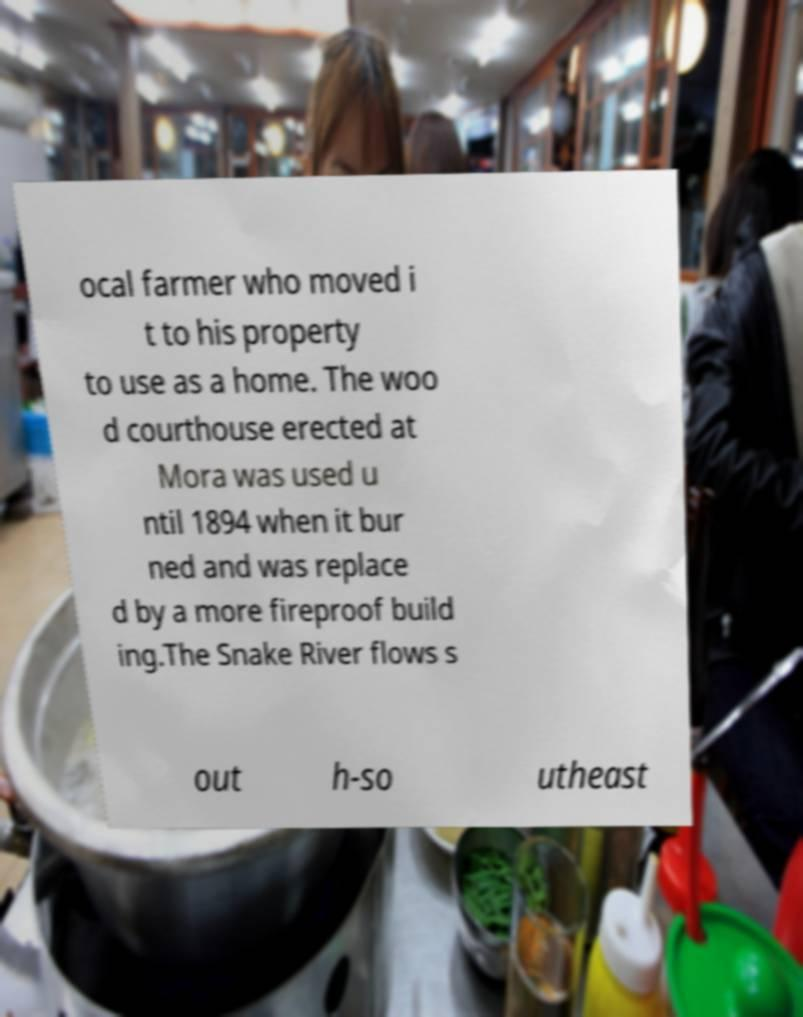Please read and relay the text visible in this image. What does it say? ocal farmer who moved i t to his property to use as a home. The woo d courthouse erected at Mora was used u ntil 1894 when it bur ned and was replace d by a more fireproof build ing.The Snake River flows s out h-so utheast 